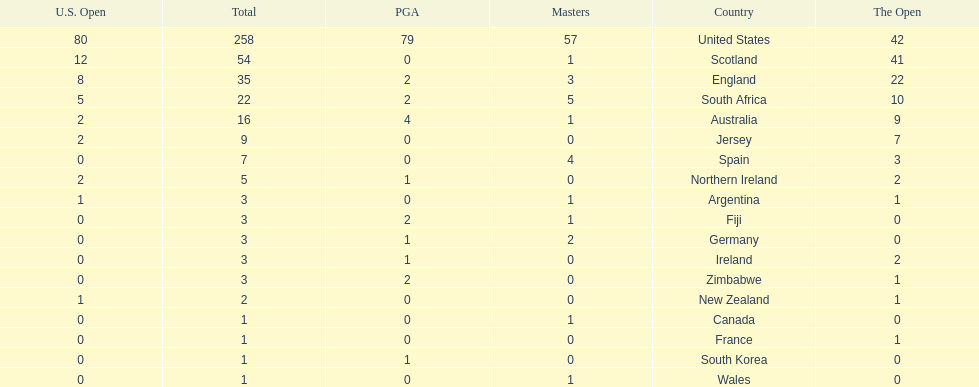How many total championships does spain have? 7. 